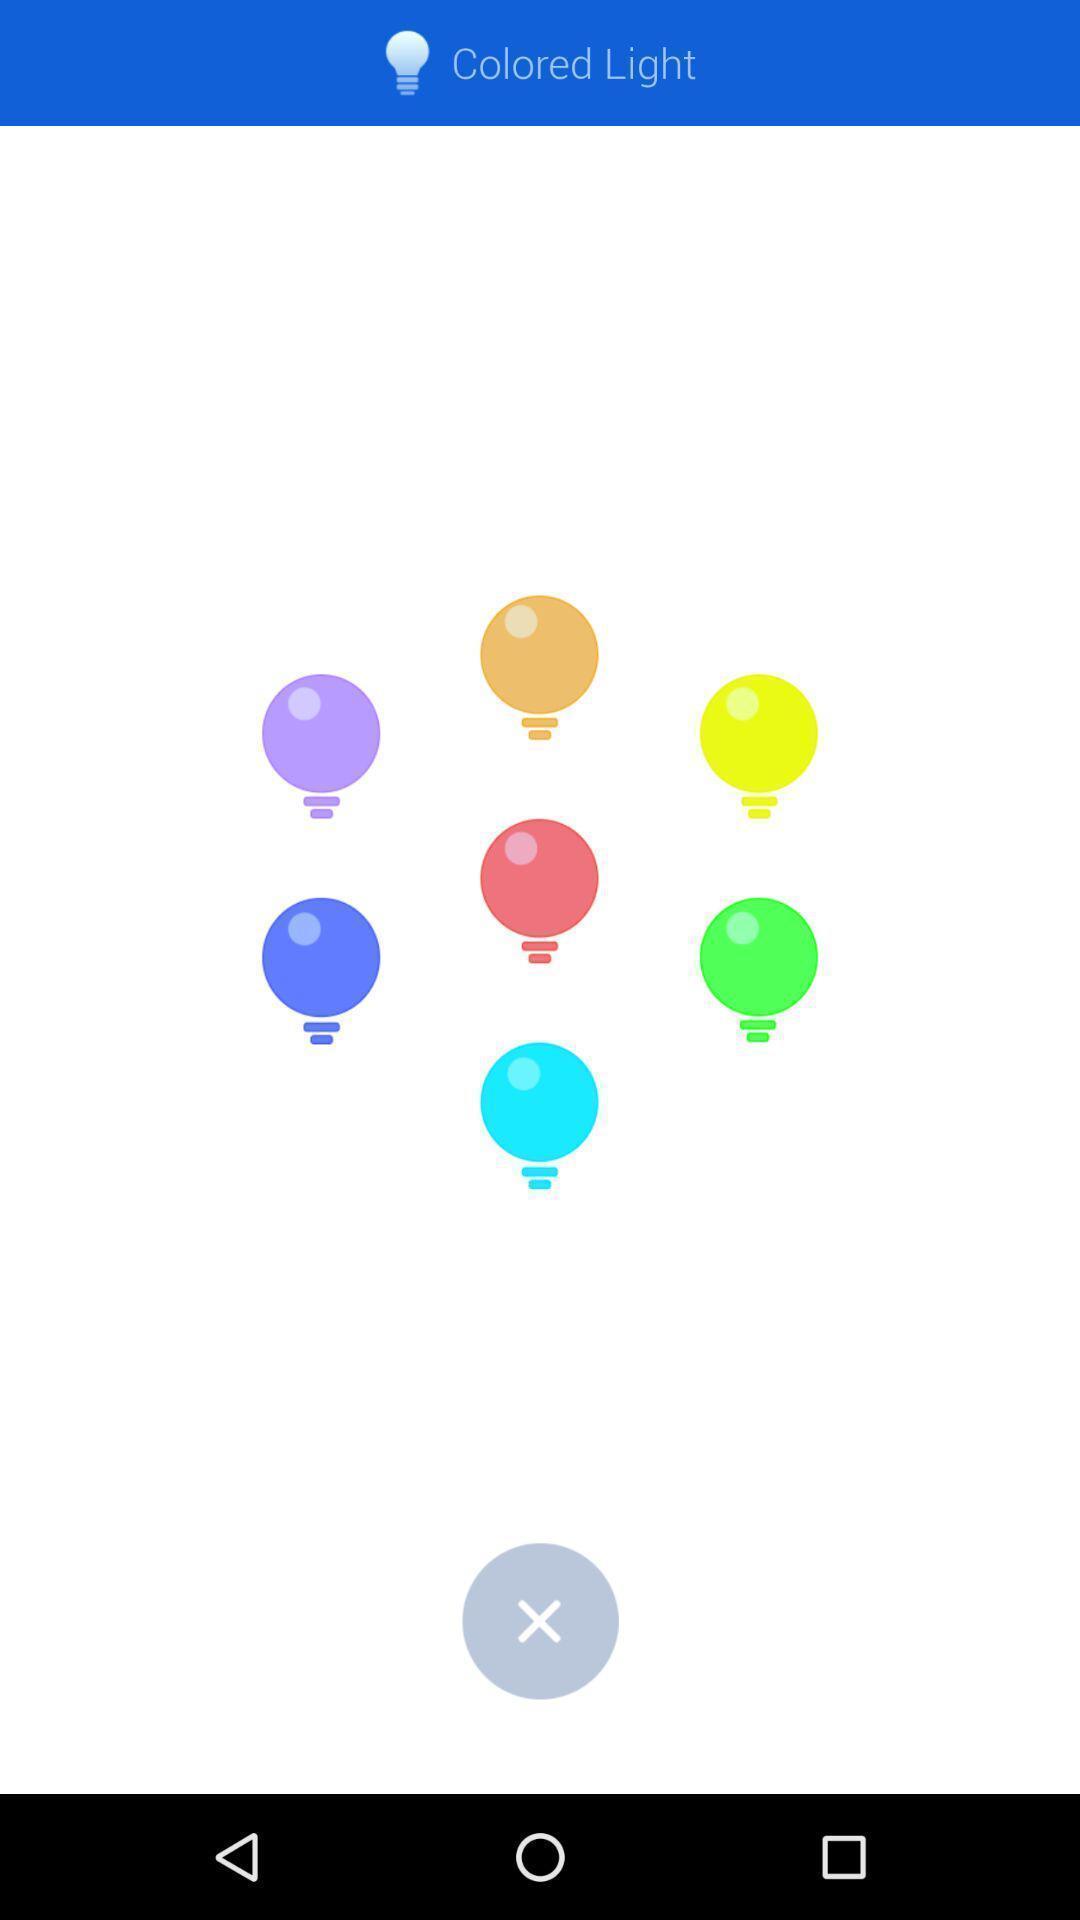Summarize the main components in this picture. Screen displaying the various colored lights. 